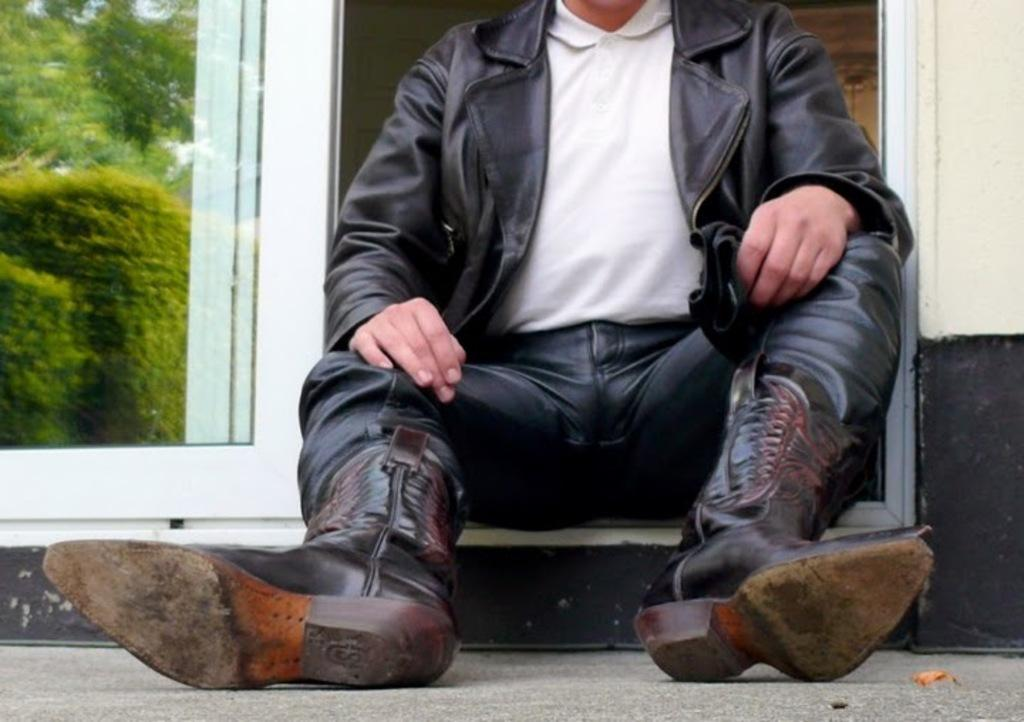What is the main subject of the image? There is a person in the image. What can be seen in the reflection on the glass at the left side of the image? The reflection of trees is visible on the glass at the left side of the image. What type of quiver is the person holding in the image? There is no quiver present in the image. Is the person driving a vehicle in the image? There is no vehicle or indication of driving in the image. 